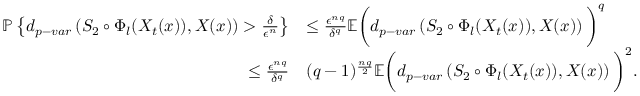<formula> <loc_0><loc_0><loc_500><loc_500>\begin{array} { r l } { \mathbb { P } \left \{ d _ { p - v a r } \left ( S _ { 2 } \circ \Phi _ { l } ( X _ { t } ( x ) ) , X ( x ) \right ) > \frac { \delta } { \epsilon ^ { n } } \right \} } & { \leq \frac { \epsilon ^ { n q } } { \delta ^ { q } } \mathbb { E } \left ( d _ { p - v a r } \left ( S _ { 2 } \circ \Phi _ { l } ( X _ { t } ( x ) ) , X ( x ) \right ) \right ) ^ { q } } \\ { \leq \frac { \epsilon ^ { n q } } { \delta ^ { q } } } & { ( q - 1 ) ^ { \frac { n q } { 2 } } \mathbb { E } \left ( d _ { p - v a r } \left ( S _ { 2 } \circ \Phi _ { l } ( X _ { t } ( x ) ) , X ( x ) \right ) \right ) ^ { 2 } . } \end{array}</formula> 